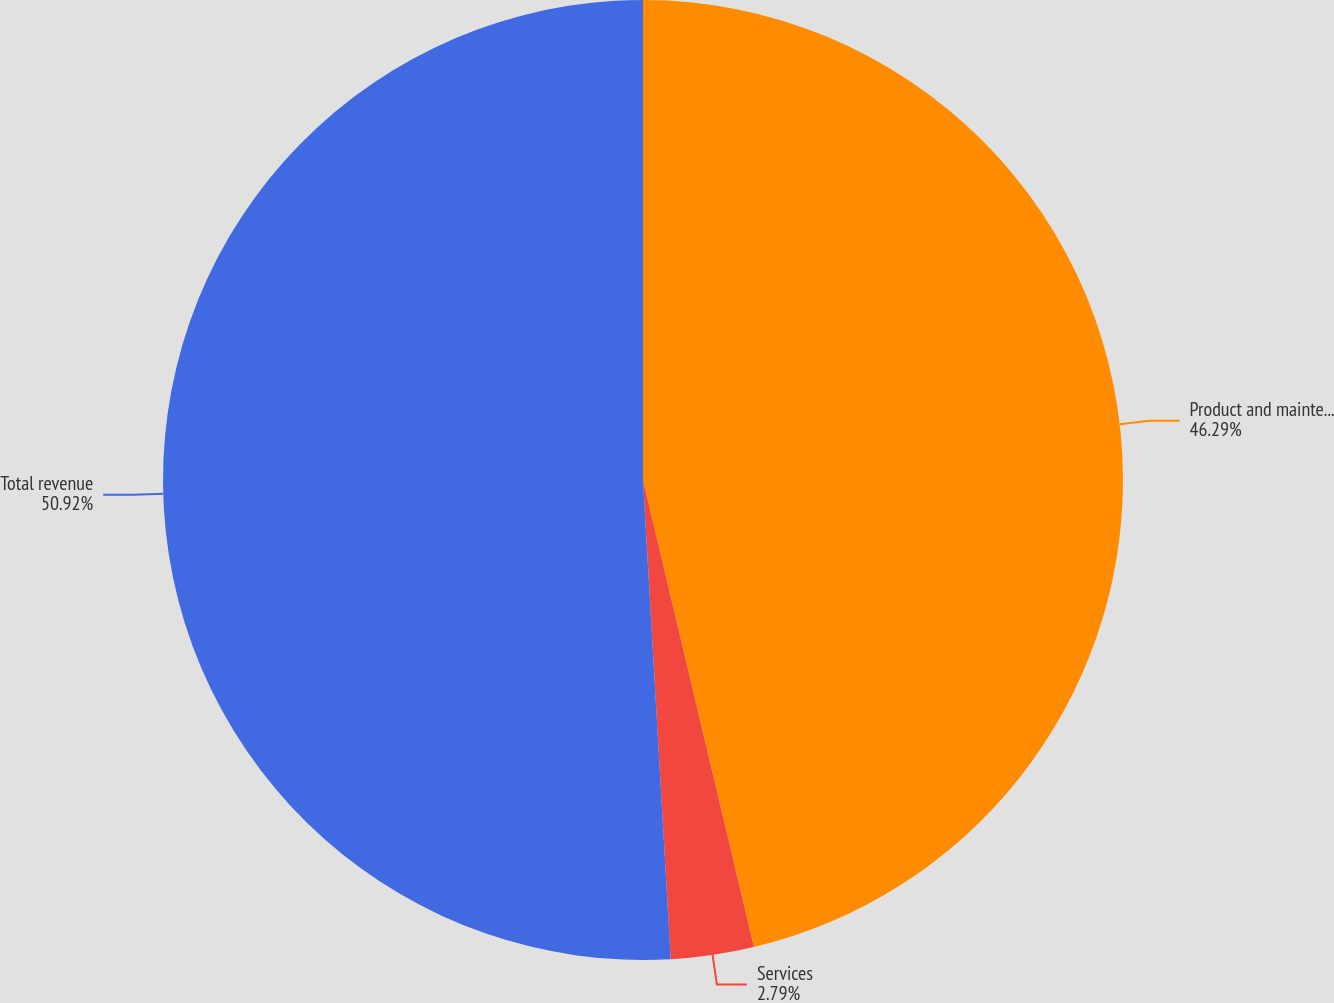Convert chart to OTSL. <chart><loc_0><loc_0><loc_500><loc_500><pie_chart><fcel>Product and maintenance<fcel>Services<fcel>Total revenue<nl><fcel>46.29%<fcel>2.79%<fcel>50.92%<nl></chart> 